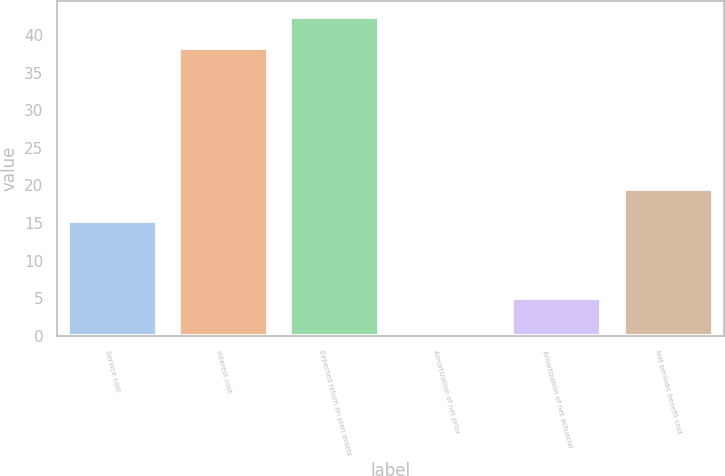Convert chart. <chart><loc_0><loc_0><loc_500><loc_500><bar_chart><fcel>Service cost<fcel>Interest cost<fcel>Expected return on plan assets<fcel>Amortization of net prior<fcel>Amortization of net actuarial<fcel>Net periodic benefit cost<nl><fcel>15.3<fcel>38.2<fcel>42.42<fcel>0.1<fcel>5<fcel>19.52<nl></chart> 